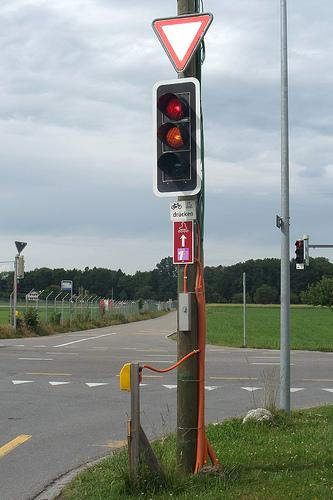Question: what color is the grass?
Choices:
A. Brown.
B. Green.
C. Red.
D. Yellow.
Answer with the letter. Answer: B Question: where was this photo taken?
Choices:
A. At the beach.
B. On a street corner.
C. In a forest.
D. At the park.
Answer with the letter. Answer: B Question: how many traffic lights are in photo?
Choices:
A. 3.
B. 4.
C. 1.
D. 2.
Answer with the letter. Answer: D Question: when was this photo taken?
Choices:
A. In the daytime.
B. At sunset.
C. After dark.
D. At sunrise.
Answer with the letter. Answer: A 